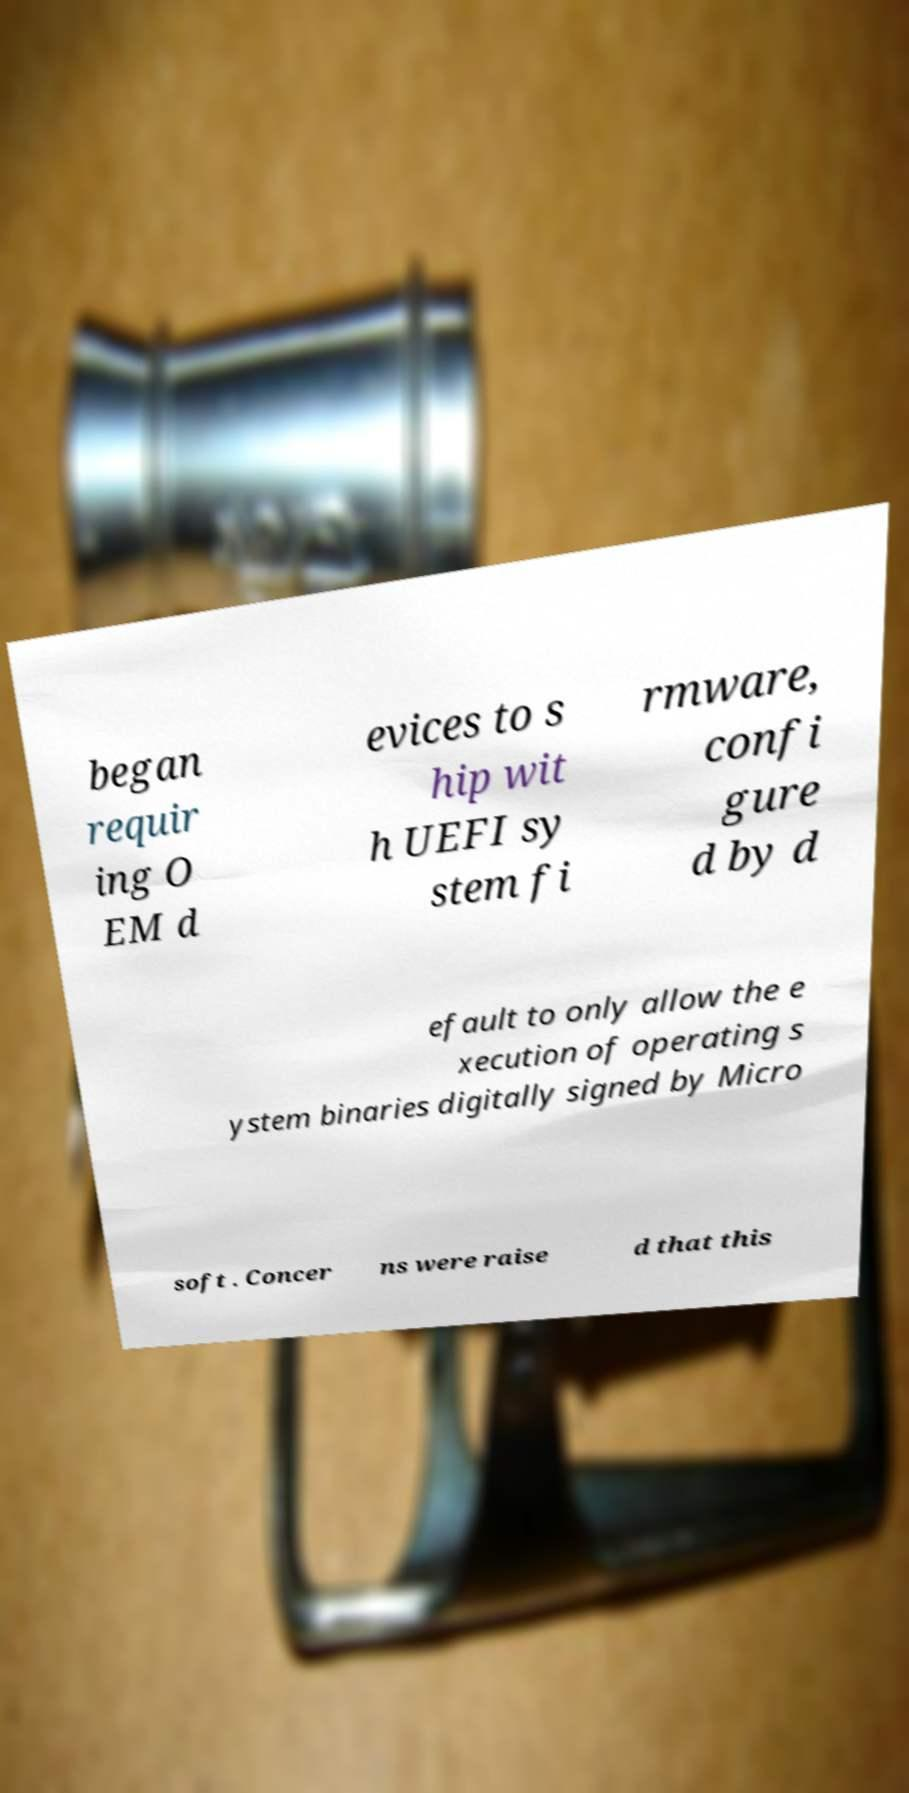Please read and relay the text visible in this image. What does it say? began requir ing O EM d evices to s hip wit h UEFI sy stem fi rmware, confi gure d by d efault to only allow the e xecution of operating s ystem binaries digitally signed by Micro soft . Concer ns were raise d that this 